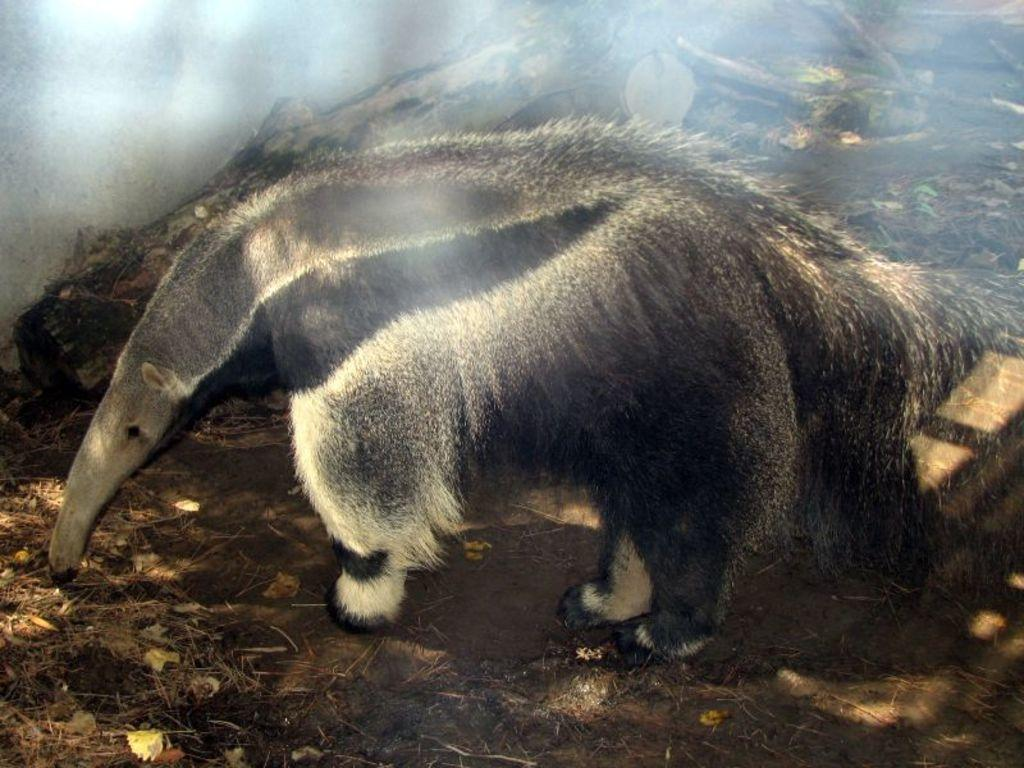What is the main subject in the center of the image? There is an animal in the center of the image. What is the animal doing in the image? The animal is standing. What can be seen on the ground in the image? There are dry leaves on the ground in the image. What type of friction can be observed between the animal's paws and the ground in the image? There is no information about the type of friction between the animal's paws and the ground in the image. --- 